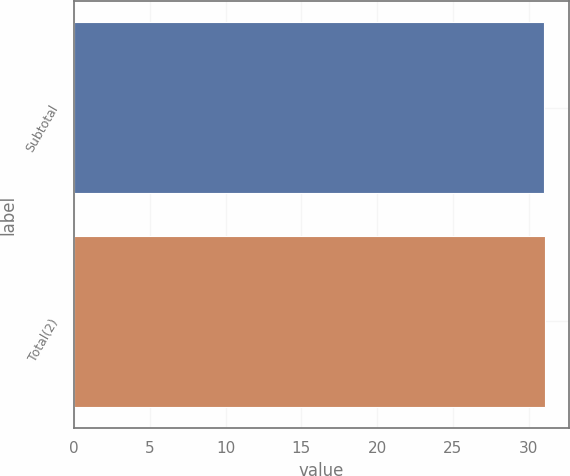Convert chart to OTSL. <chart><loc_0><loc_0><loc_500><loc_500><bar_chart><fcel>Subtotal<fcel>Total(2)<nl><fcel>31<fcel>31.1<nl></chart> 